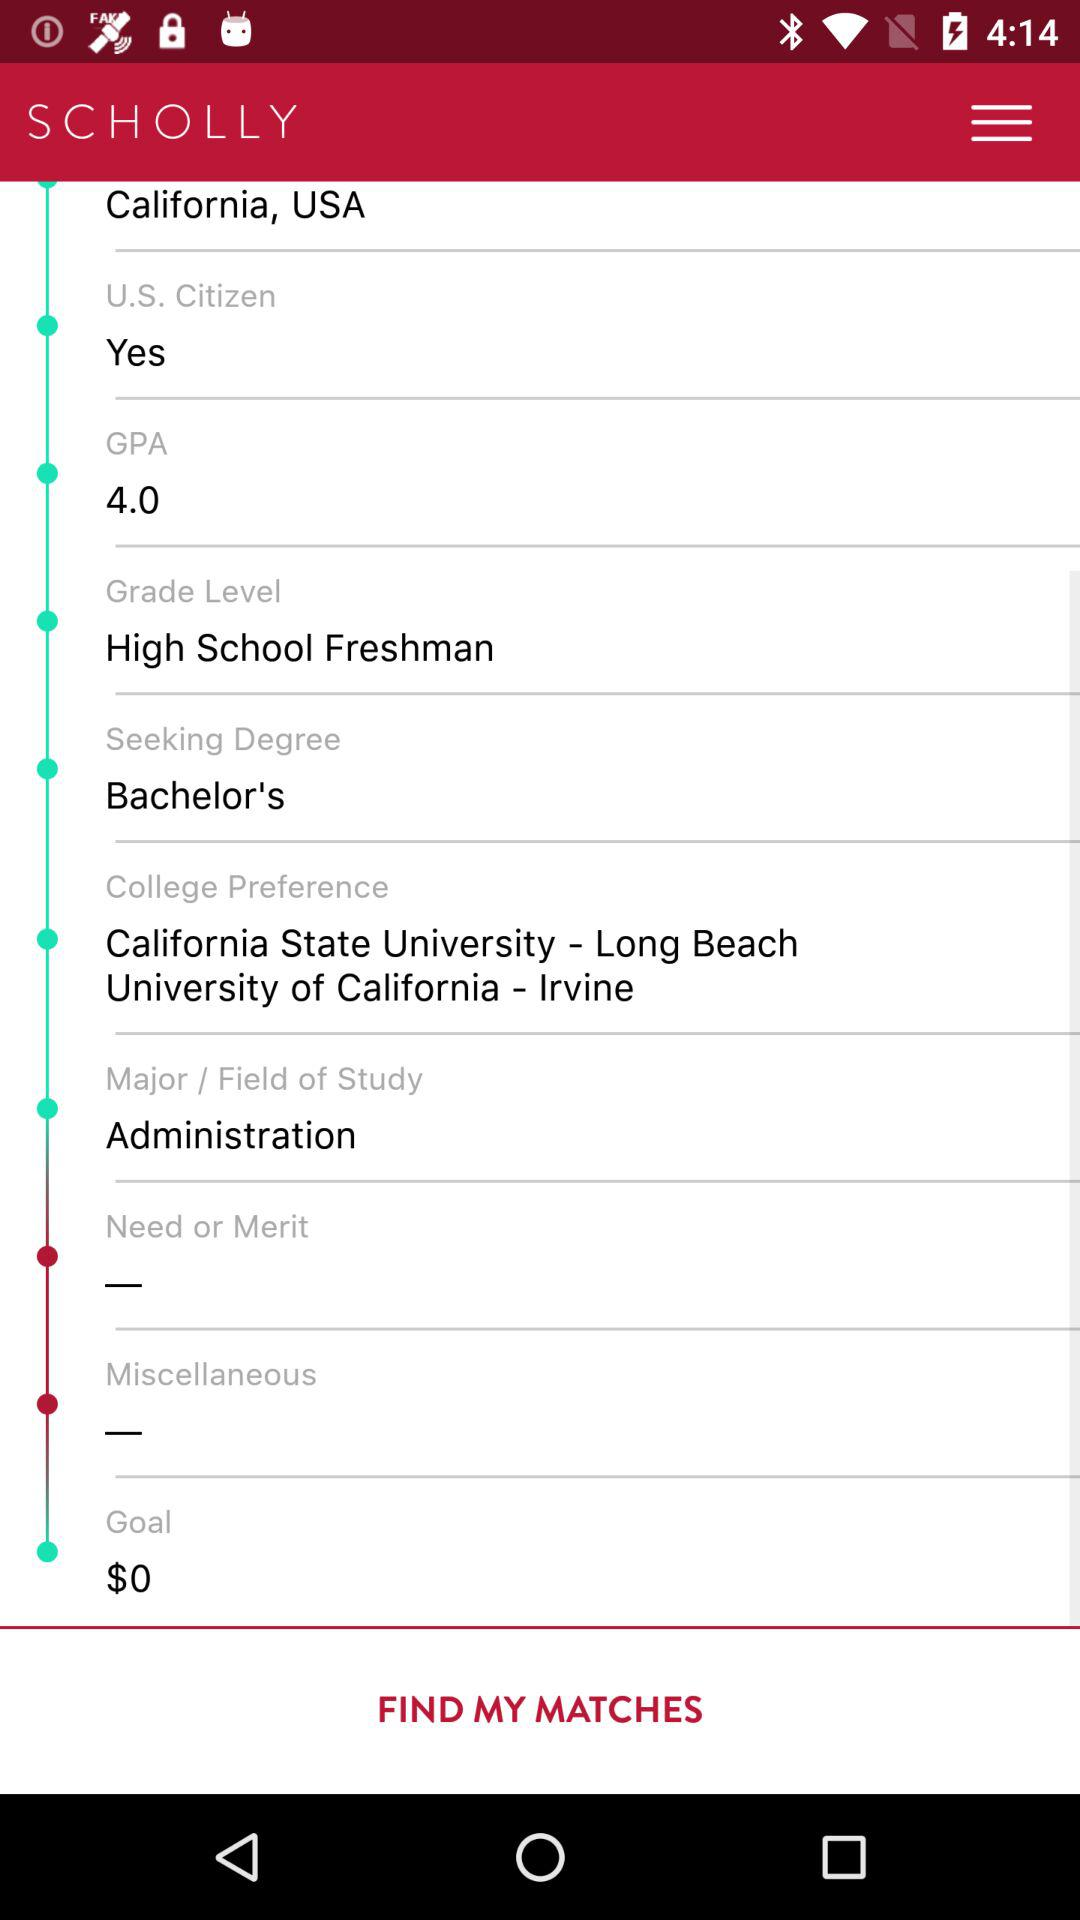What is "College Preference"? The "College Preference" is "California State University - Long Beach University of California - Irvine". 